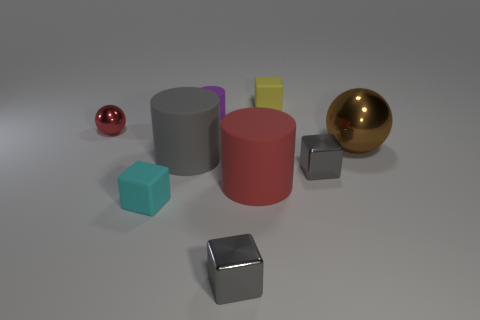Is there a big matte cylinder of the same color as the tiny ball?
Make the answer very short. Yes. How many matte cylinders have the same color as the small metallic sphere?
Your answer should be very brief. 1. There is a small sphere; does it have the same color as the large matte cylinder in front of the gray matte cylinder?
Provide a short and direct response. Yes. Is there any other thing that has the same color as the small metallic sphere?
Keep it short and to the point. Yes. Is there a yellow thing of the same shape as the cyan object?
Your answer should be very brief. Yes. What number of other things are the same shape as the large brown thing?
Give a very brief answer. 1. There is a small shiny object that is behind the cyan cube and to the right of the tiny red ball; what shape is it?
Your response must be concise. Cube. There is a red object left of the purple rubber cylinder; what size is it?
Provide a succinct answer. Small. Is the purple rubber thing the same size as the gray cylinder?
Your answer should be very brief. No. Are there fewer cyan things that are behind the purple rubber cylinder than yellow matte blocks that are in front of the red metallic sphere?
Your answer should be very brief. No. 